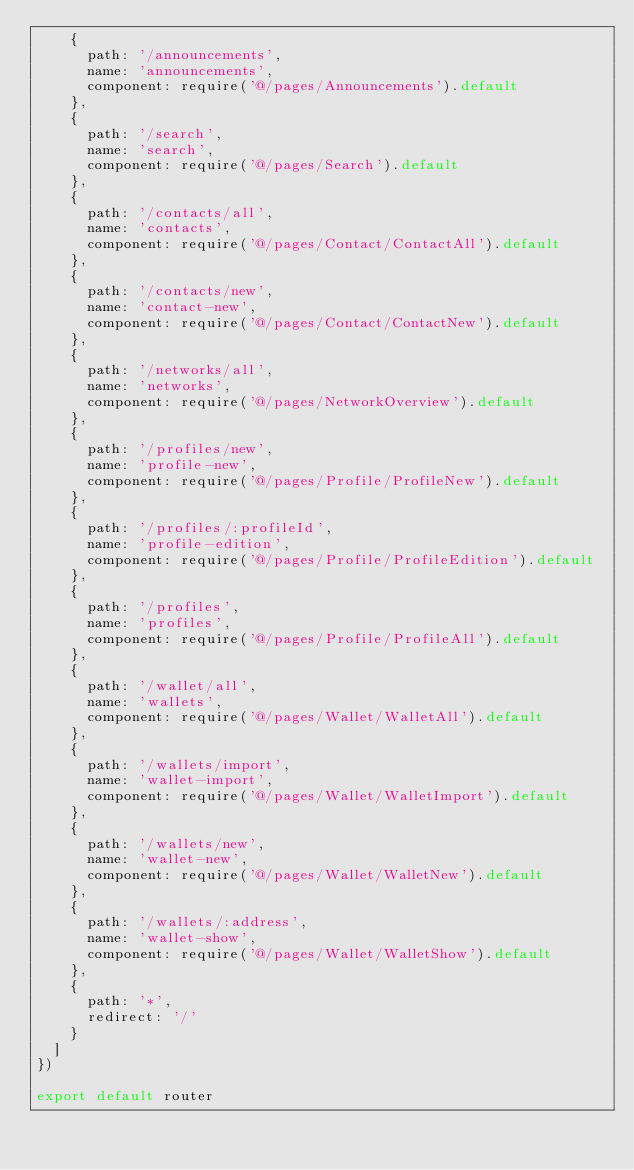Convert code to text. <code><loc_0><loc_0><loc_500><loc_500><_JavaScript_>    {
      path: '/announcements',
      name: 'announcements',
      component: require('@/pages/Announcements').default
    },
    {
      path: '/search',
      name: 'search',
      component: require('@/pages/Search').default
    },
    {
      path: '/contacts/all',
      name: 'contacts',
      component: require('@/pages/Contact/ContactAll').default
    },
    {
      path: '/contacts/new',
      name: 'contact-new',
      component: require('@/pages/Contact/ContactNew').default
    },
    {
      path: '/networks/all',
      name: 'networks',
      component: require('@/pages/NetworkOverview').default
    },
    {
      path: '/profiles/new',
      name: 'profile-new',
      component: require('@/pages/Profile/ProfileNew').default
    },
    {
      path: '/profiles/:profileId',
      name: 'profile-edition',
      component: require('@/pages/Profile/ProfileEdition').default
    },
    {
      path: '/profiles',
      name: 'profiles',
      component: require('@/pages/Profile/ProfileAll').default
    },
    {
      path: '/wallet/all',
      name: 'wallets',
      component: require('@/pages/Wallet/WalletAll').default
    },
    {
      path: '/wallets/import',
      name: 'wallet-import',
      component: require('@/pages/Wallet/WalletImport').default
    },
    {
      path: '/wallets/new',
      name: 'wallet-new',
      component: require('@/pages/Wallet/WalletNew').default
    },
    {
      path: '/wallets/:address',
      name: 'wallet-show',
      component: require('@/pages/Wallet/WalletShow').default
    },
    {
      path: '*',
      redirect: '/'
    }
  ]
})

export default router
</code> 